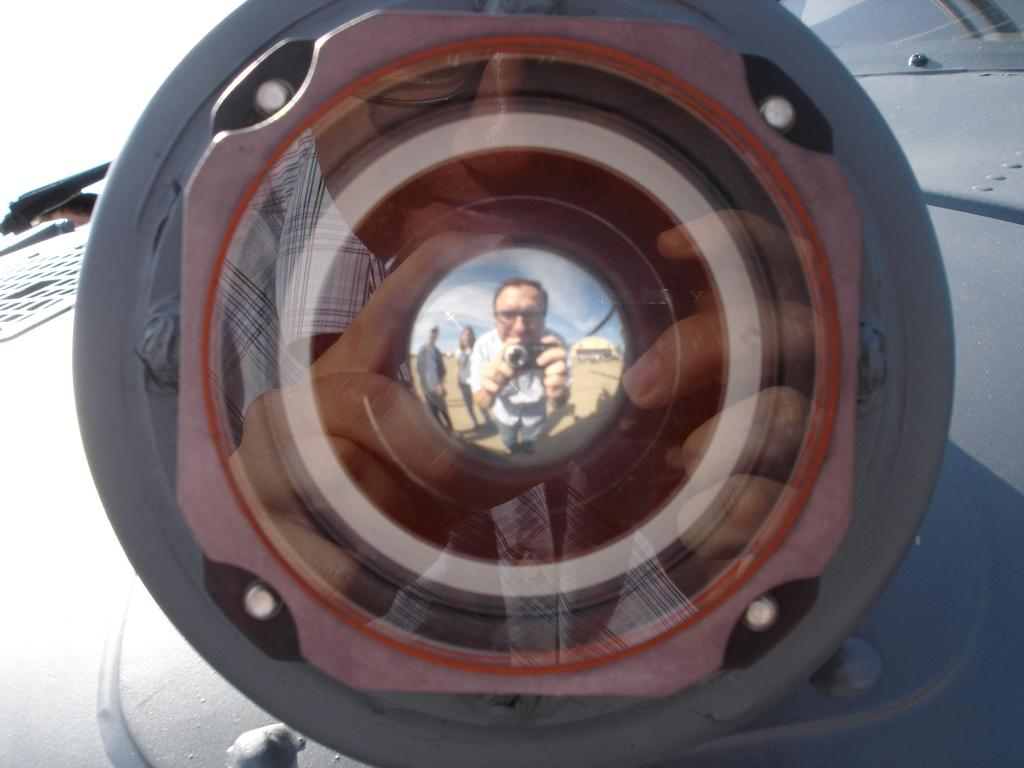What is the main subject of the image? There is an object in the image. Can you describe the object's location? The object is on a surface. What can be seen in the object's reflection? There is a reflection of a person taking a photo in the object. Are there any other people visible in the image? Yes, there are two more persons standing behind the person taking the photo. What type of holiday is being celebrated in the image? There is no indication of a holiday being celebrated in the image. How far can the person taking the photo stretch their arms in the image? The image does not provide information about the person's ability to stretch their arms. 